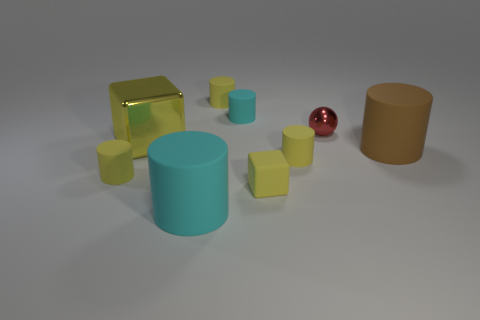Which objects in the image could be considered as having a matte surface finish? The cyan-colored cylinders exhibit a matte surface finish, as they do not reflect light as vividly as the shiny red sphere. 